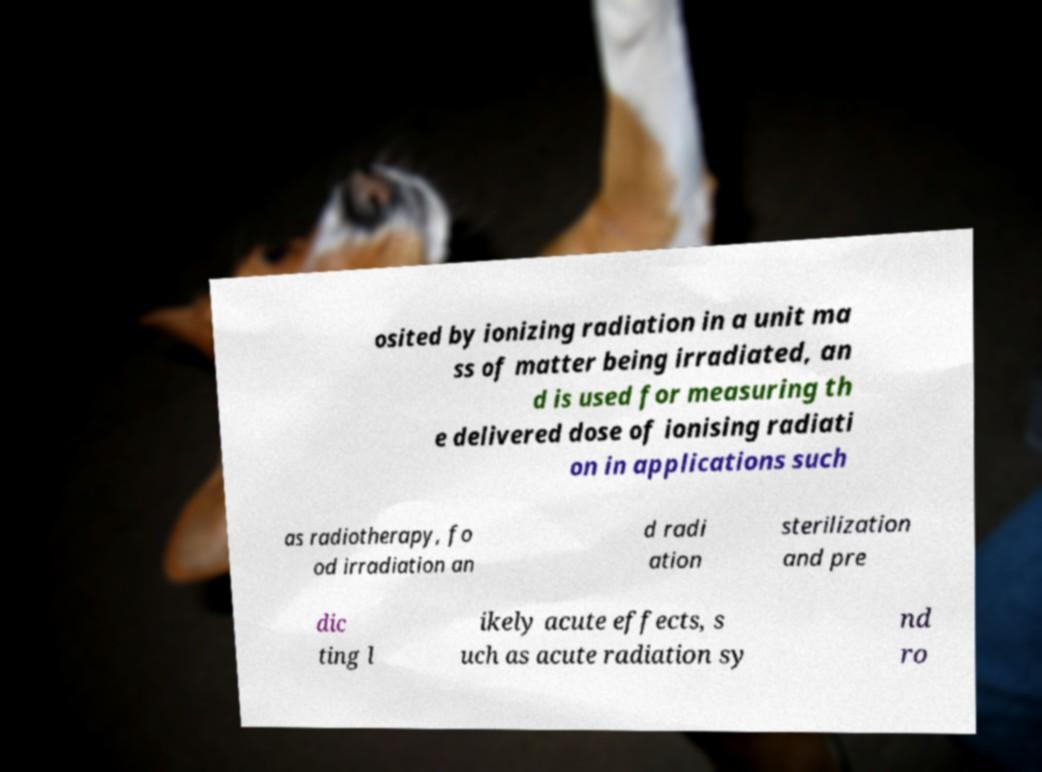Please identify and transcribe the text found in this image. osited by ionizing radiation in a unit ma ss of matter being irradiated, an d is used for measuring th e delivered dose of ionising radiati on in applications such as radiotherapy, fo od irradiation an d radi ation sterilization and pre dic ting l ikely acute effects, s uch as acute radiation sy nd ro 